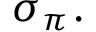<formula> <loc_0><loc_0><loc_500><loc_500>\sigma _ { \pi } \, .</formula> 